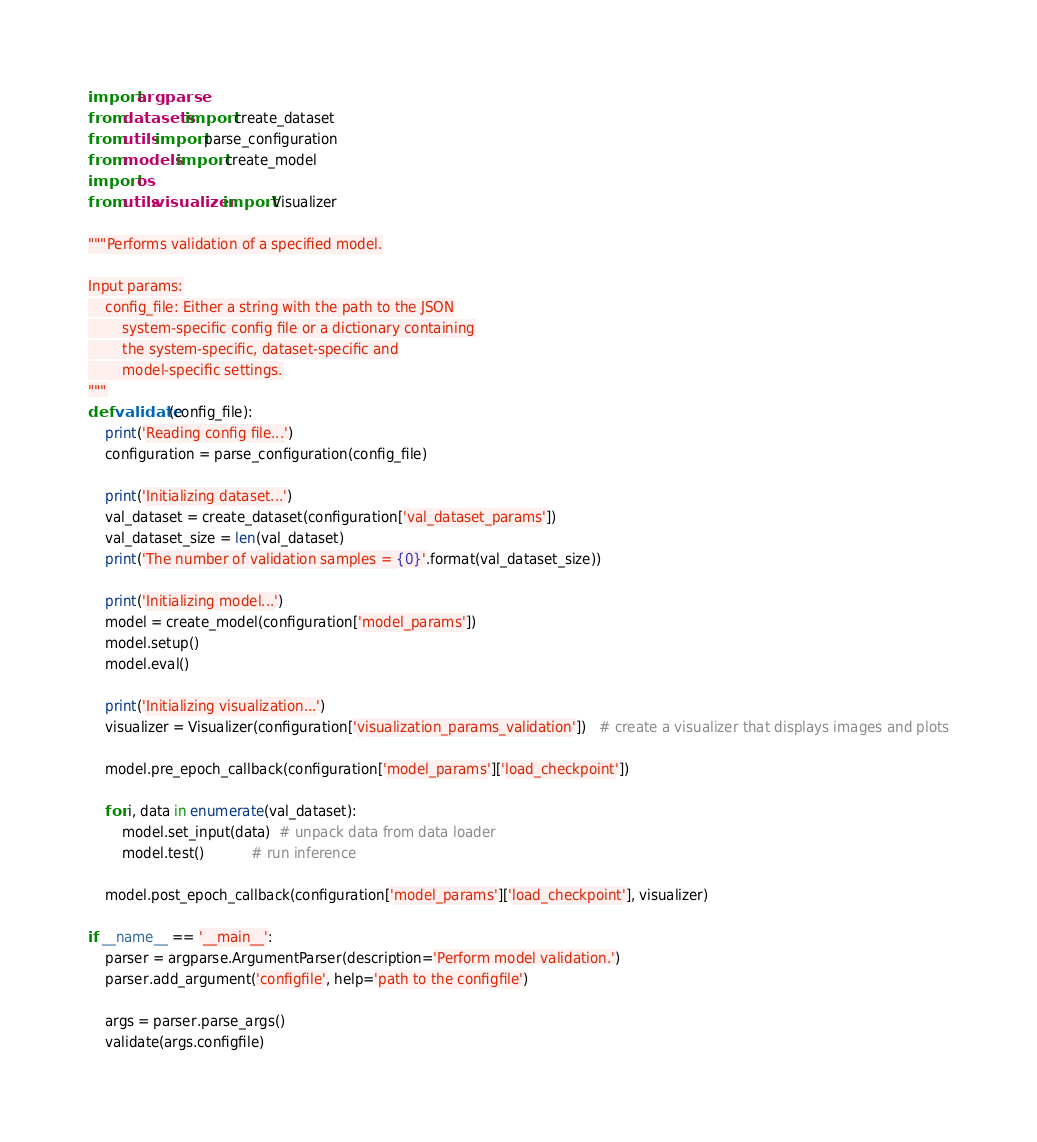<code> <loc_0><loc_0><loc_500><loc_500><_Python_>import argparse
from datasets import create_dataset
from utils import parse_configuration
from models import create_model
import os
from utils.visualizer import Visualizer

"""Performs validation of a specified model.

Input params:
    config_file: Either a string with the path to the JSON
        system-specific config file or a dictionary containing
        the system-specific, dataset-specific and
        model-specific settings.
"""
def validate(config_file):
    print('Reading config file...')
    configuration = parse_configuration(config_file)

    print('Initializing dataset...')
    val_dataset = create_dataset(configuration['val_dataset_params'])
    val_dataset_size = len(val_dataset)
    print('The number of validation samples = {0}'.format(val_dataset_size))

    print('Initializing model...')
    model = create_model(configuration['model_params'])
    model.setup()
    model.eval()

    print('Initializing visualization...')
    visualizer = Visualizer(configuration['visualization_params_validation'])   # create a visualizer that displays images and plots

    model.pre_epoch_callback(configuration['model_params']['load_checkpoint'])

    for i, data in enumerate(val_dataset):
        model.set_input(data)  # unpack data from data loader
        model.test()           # run inference

    model.post_epoch_callback(configuration['model_params']['load_checkpoint'], visualizer)

if __name__ == '__main__':
    parser = argparse.ArgumentParser(description='Perform model validation.')
    parser.add_argument('configfile', help='path to the configfile')

    args = parser.parse_args()
    validate(args.configfile)
</code> 